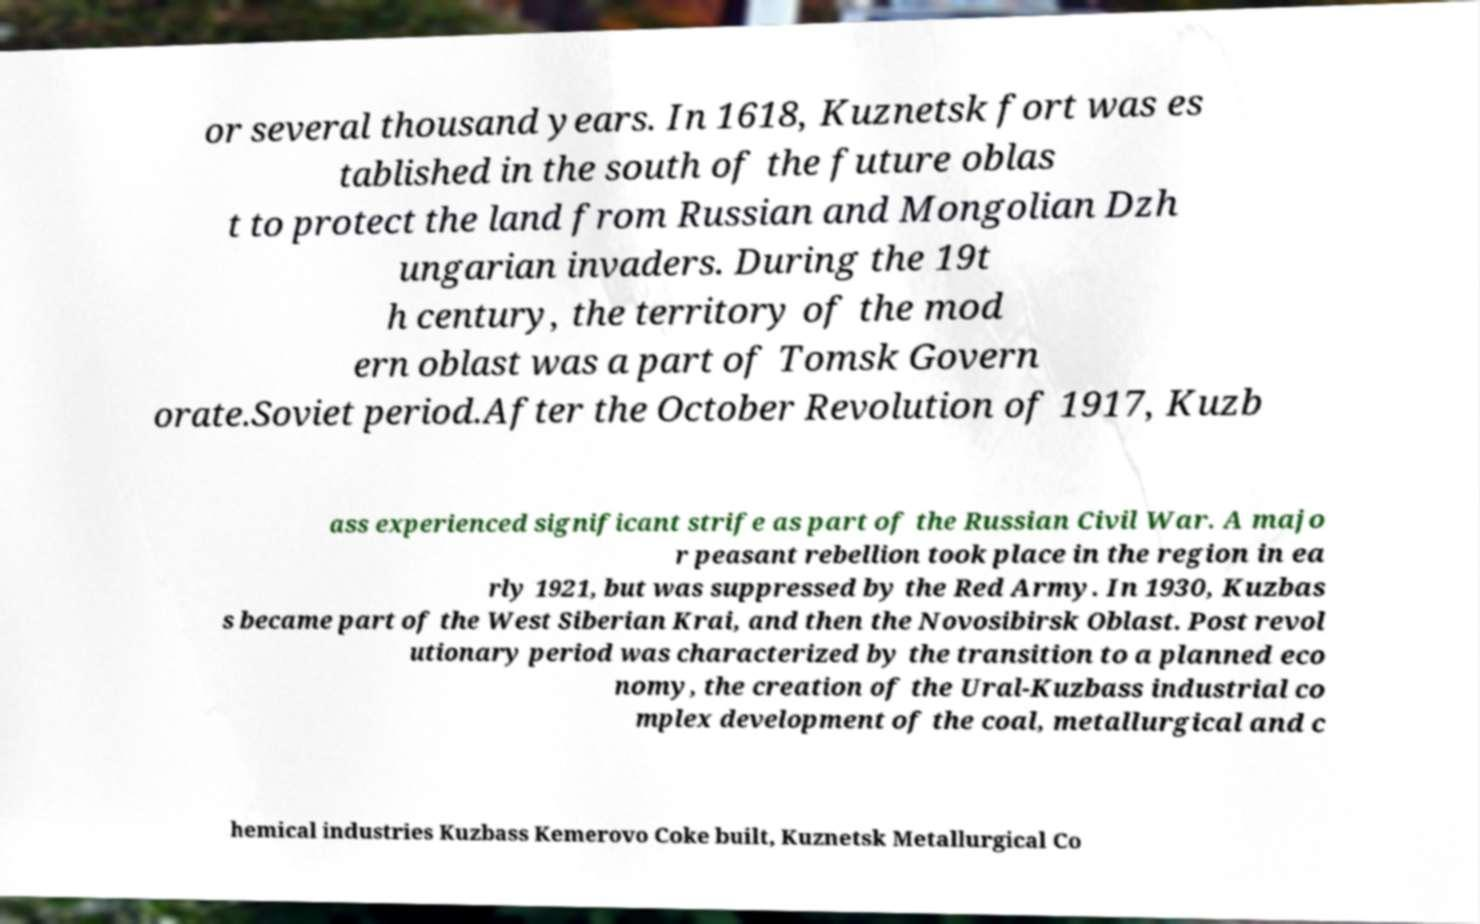Could you extract and type out the text from this image? or several thousand years. In 1618, Kuznetsk fort was es tablished in the south of the future oblas t to protect the land from Russian and Mongolian Dzh ungarian invaders. During the 19t h century, the territory of the mod ern oblast was a part of Tomsk Govern orate.Soviet period.After the October Revolution of 1917, Kuzb ass experienced significant strife as part of the Russian Civil War. A majo r peasant rebellion took place in the region in ea rly 1921, but was suppressed by the Red Army. In 1930, Kuzbas s became part of the West Siberian Krai, and then the Novosibirsk Oblast. Post revol utionary period was characterized by the transition to a planned eco nomy, the creation of the Ural-Kuzbass industrial co mplex development of the coal, metallurgical and c hemical industries Kuzbass Kemerovo Coke built, Kuznetsk Metallurgical Co 